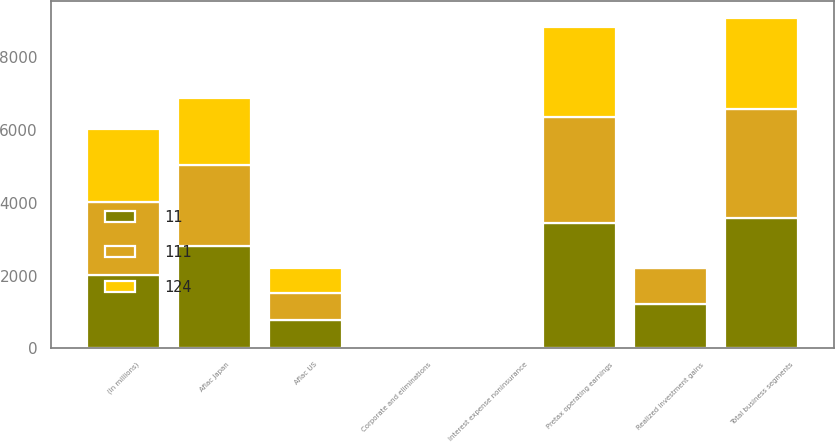Convert chart. <chart><loc_0><loc_0><loc_500><loc_500><stacked_bar_chart><ecel><fcel>(In millions)<fcel>Aflac Japan<fcel>Aflac US<fcel>Total business segments<fcel>Interest expense noninsurance<fcel>Corporate and eliminations<fcel>Pretax operating earnings<fcel>Realized investment gains<nl><fcel>11<fcel>2009<fcel>2800<fcel>776<fcel>3576<fcel>73<fcel>68<fcel>3435<fcel>1212<nl><fcel>111<fcel>2008<fcel>2250<fcel>745<fcel>2994<fcel>26<fcel>42<fcel>2926<fcel>1007<nl><fcel>124<fcel>2007<fcel>1821<fcel>692<fcel>2513<fcel>21<fcel>25<fcel>2467<fcel>28<nl></chart> 